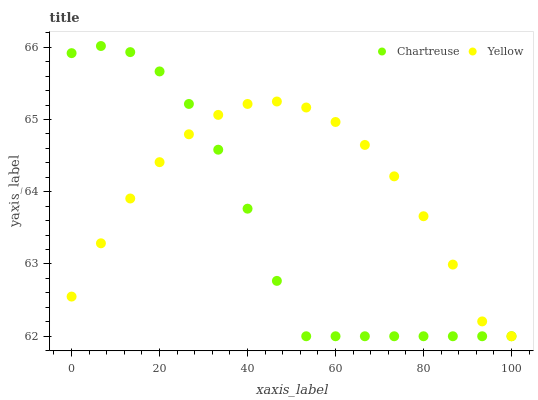Does Chartreuse have the minimum area under the curve?
Answer yes or no. Yes. Does Yellow have the maximum area under the curve?
Answer yes or no. Yes. Does Yellow have the minimum area under the curve?
Answer yes or no. No. Is Chartreuse the smoothest?
Answer yes or no. Yes. Is Yellow the roughest?
Answer yes or no. Yes. Is Yellow the smoothest?
Answer yes or no. No. Does Chartreuse have the lowest value?
Answer yes or no. Yes. Does Chartreuse have the highest value?
Answer yes or no. Yes. Does Yellow have the highest value?
Answer yes or no. No. Does Yellow intersect Chartreuse?
Answer yes or no. Yes. Is Yellow less than Chartreuse?
Answer yes or no. No. Is Yellow greater than Chartreuse?
Answer yes or no. No. 